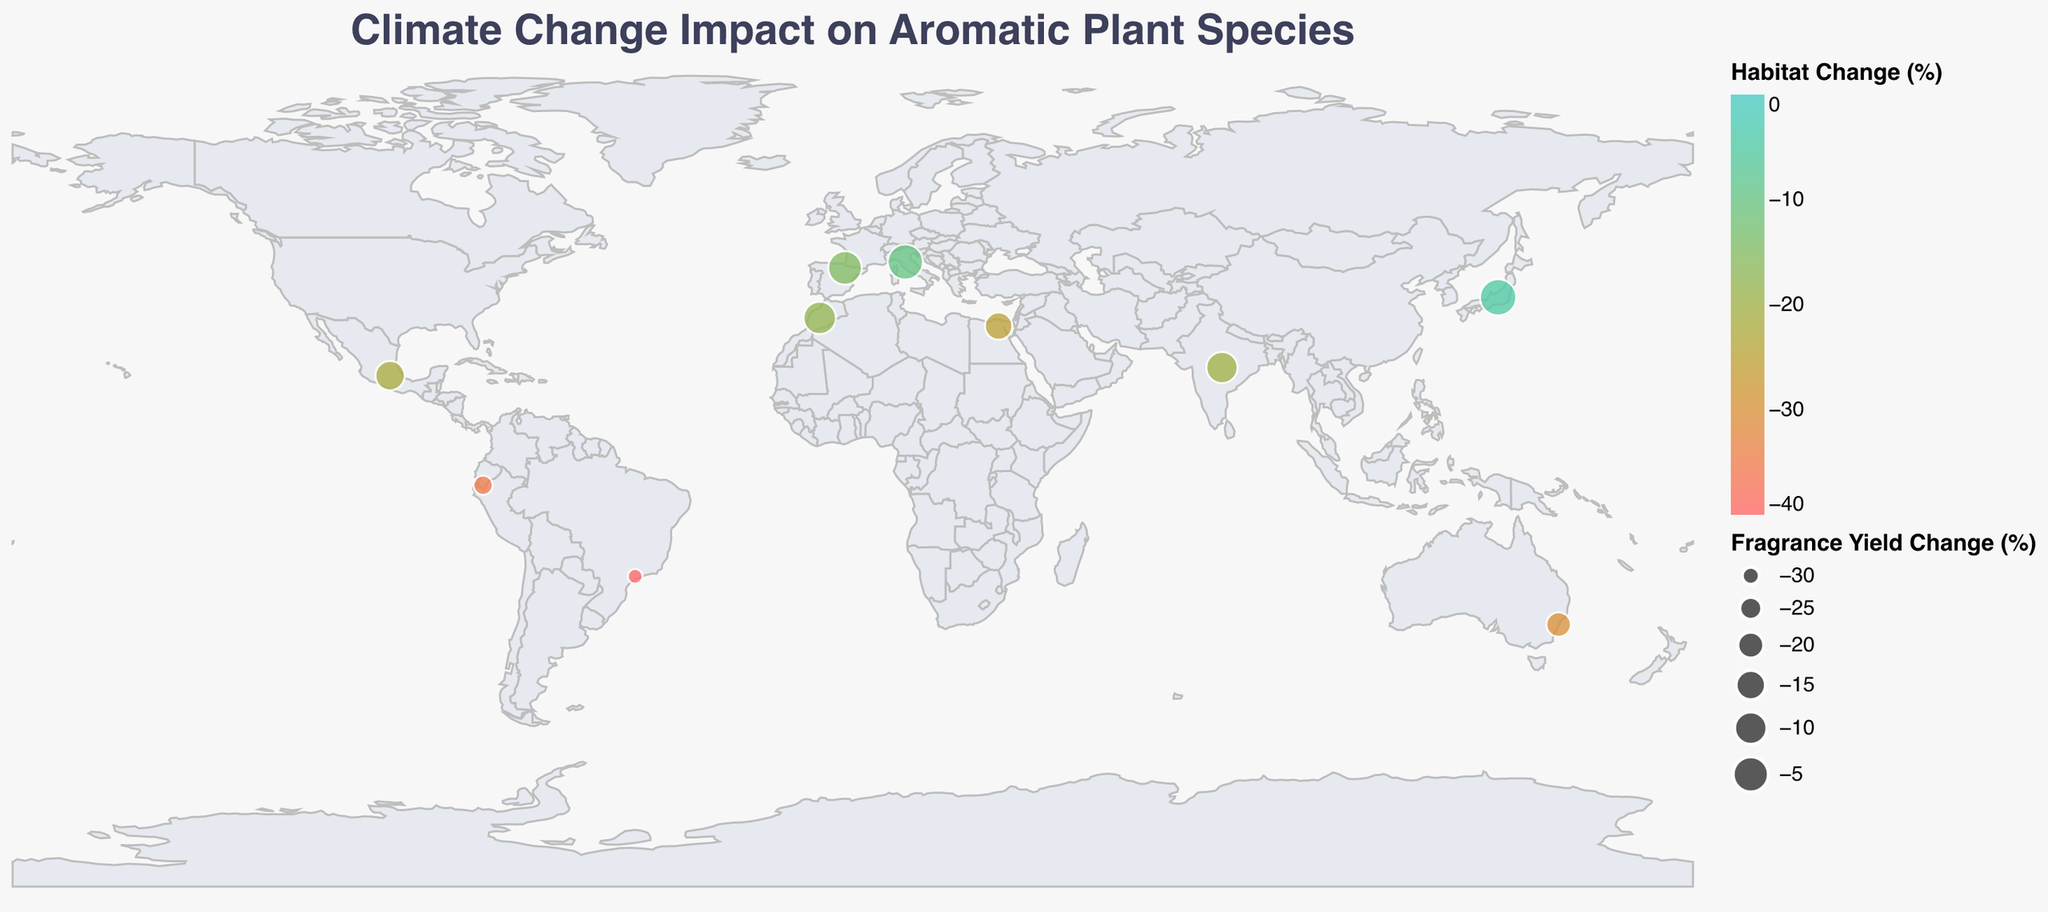What is the title of the figure? The title is generally displayed at the top center of the figure.
Answer: Climate Change Impact on Aromatic Plant Species How many countries are represented in the figure? By counting the unique entries in the "Country" field in the plot.
Answer: 10 Which species shows the largest habitat decrease? Look at the color gradient and tooltip for the species with the most negative habitat change value.
Answer: Aniba rosaeodora Which country has the species with the smallest decrease in fragrance yield? Check the tooltip information and size of the circles to identify the smallest fragrance yield change.
Answer: Japan What color represents a 0% habitat change in the plot? Look at the legend's description of the color gradient for habitat changes.
Answer: #4ECDC4 (greenish) What are the two countries with the most significant habitat decline, and what's the combined percentage? Identify the two countries with the most significant negative habitat change from the figure and sum their values.
Answer: Ecuador and Brazil; -75% Compare the fragrance yield changes of Lavandula angustifolia and Rosa centifolia. Which has a smaller decline? Check the figure and tooltip for the fragrance yield change values of these species and compare.
Answer: Rosa centifolia What is the average fragrance yield change across all species depicted? Sum all the fragrance yield changes and divide by the number of species. (-8 + -5 + -18 + -22 + -12 + -28 + -3 + -10 + -32 + -15) / 10
Answer: -15.3% Which continent has the most species affected by climate change in this figure? Determine the continents where the countries are located and count the occurrences.
Answer: Asia (India and Japan) What is the range of habitat change values depicted in the figure? Look at the legend for habitat change to find the minimum and maximum values mapped.
Answer: -40% to -5% 